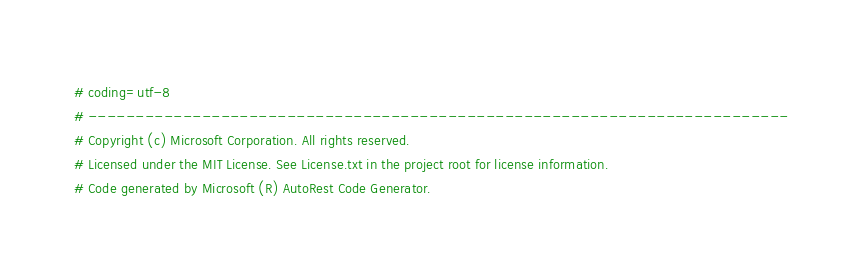Convert code to text. <code><loc_0><loc_0><loc_500><loc_500><_Python_># coding=utf-8
# --------------------------------------------------------------------------
# Copyright (c) Microsoft Corporation. All rights reserved.
# Licensed under the MIT License. See License.txt in the project root for license information.
# Code generated by Microsoft (R) AutoRest Code Generator.</code> 